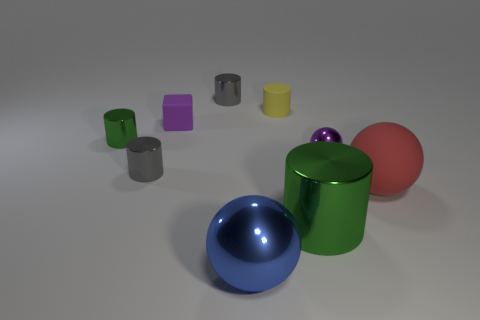Add 1 small yellow matte things. How many objects exist? 10 Subtract all balls. How many objects are left? 6 Add 3 purple metal things. How many purple metal things are left? 4 Add 1 tiny things. How many tiny things exist? 7 Subtract 1 yellow cylinders. How many objects are left? 8 Subtract all small rubber blocks. Subtract all large green metallic cylinders. How many objects are left? 7 